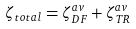<formula> <loc_0><loc_0><loc_500><loc_500>\zeta _ { t o t a l } = \zeta _ { D F } ^ { a v } + \zeta _ { T R } ^ { a v }</formula> 